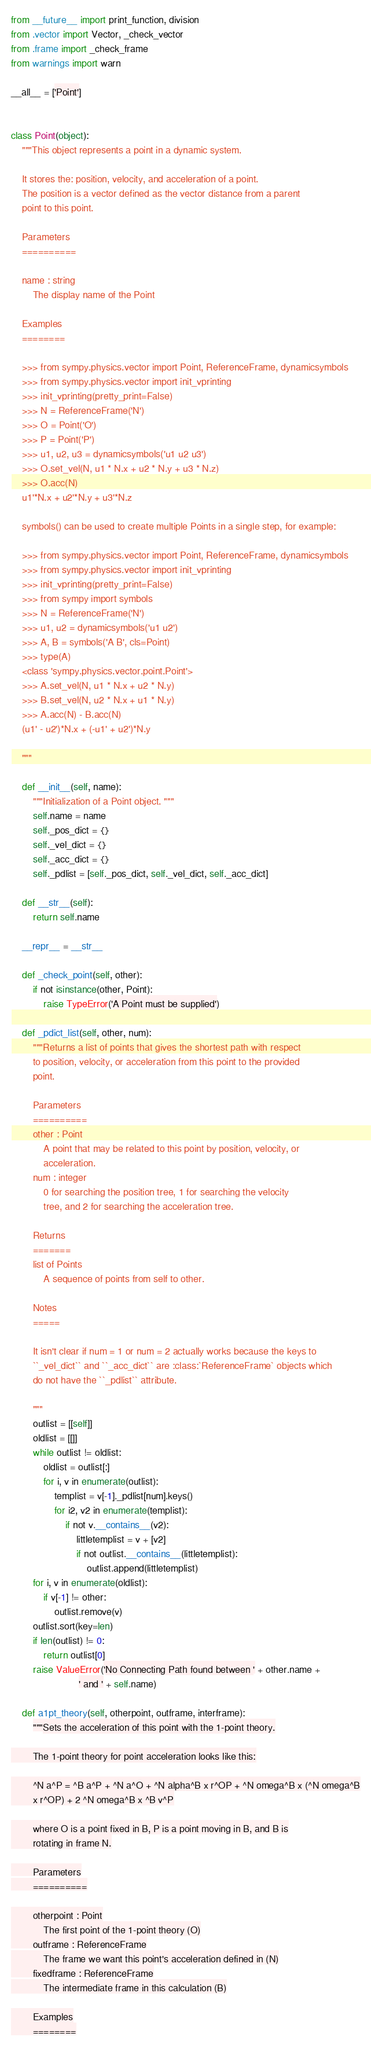Convert code to text. <code><loc_0><loc_0><loc_500><loc_500><_Python_>from __future__ import print_function, division
from .vector import Vector, _check_vector
from .frame import _check_frame
from warnings import warn

__all__ = ['Point']


class Point(object):
    """This object represents a point in a dynamic system.

    It stores the: position, velocity, and acceleration of a point.
    The position is a vector defined as the vector distance from a parent
    point to this point.

    Parameters
    ==========

    name : string
        The display name of the Point

    Examples
    ========

    >>> from sympy.physics.vector import Point, ReferenceFrame, dynamicsymbols
    >>> from sympy.physics.vector import init_vprinting
    >>> init_vprinting(pretty_print=False)
    >>> N = ReferenceFrame('N')
    >>> O = Point('O')
    >>> P = Point('P')
    >>> u1, u2, u3 = dynamicsymbols('u1 u2 u3')
    >>> O.set_vel(N, u1 * N.x + u2 * N.y + u3 * N.z)
    >>> O.acc(N)
    u1'*N.x + u2'*N.y + u3'*N.z

    symbols() can be used to create multiple Points in a single step, for example:

    >>> from sympy.physics.vector import Point, ReferenceFrame, dynamicsymbols
    >>> from sympy.physics.vector import init_vprinting
    >>> init_vprinting(pretty_print=False)
    >>> from sympy import symbols
    >>> N = ReferenceFrame('N')
    >>> u1, u2 = dynamicsymbols('u1 u2')
    >>> A, B = symbols('A B', cls=Point)
    >>> type(A)
    <class 'sympy.physics.vector.point.Point'>
    >>> A.set_vel(N, u1 * N.x + u2 * N.y)
    >>> B.set_vel(N, u2 * N.x + u1 * N.y)
    >>> A.acc(N) - B.acc(N)
    (u1' - u2')*N.x + (-u1' + u2')*N.y

    """

    def __init__(self, name):
        """Initialization of a Point object. """
        self.name = name
        self._pos_dict = {}
        self._vel_dict = {}
        self._acc_dict = {}
        self._pdlist = [self._pos_dict, self._vel_dict, self._acc_dict]

    def __str__(self):
        return self.name

    __repr__ = __str__

    def _check_point(self, other):
        if not isinstance(other, Point):
            raise TypeError('A Point must be supplied')

    def _pdict_list(self, other, num):
        """Returns a list of points that gives the shortest path with respect
        to position, velocity, or acceleration from this point to the provided
        point.

        Parameters
        ==========
        other : Point
            A point that may be related to this point by position, velocity, or
            acceleration.
        num : integer
            0 for searching the position tree, 1 for searching the velocity
            tree, and 2 for searching the acceleration tree.

        Returns
        =======
        list of Points
            A sequence of points from self to other.

        Notes
        =====

        It isn't clear if num = 1 or num = 2 actually works because the keys to
        ``_vel_dict`` and ``_acc_dict`` are :class:`ReferenceFrame` objects which
        do not have the ``_pdlist`` attribute.

        """
        outlist = [[self]]
        oldlist = [[]]
        while outlist != oldlist:
            oldlist = outlist[:]
            for i, v in enumerate(outlist):
                templist = v[-1]._pdlist[num].keys()
                for i2, v2 in enumerate(templist):
                    if not v.__contains__(v2):
                        littletemplist = v + [v2]
                        if not outlist.__contains__(littletemplist):
                            outlist.append(littletemplist)
        for i, v in enumerate(oldlist):
            if v[-1] != other:
                outlist.remove(v)
        outlist.sort(key=len)
        if len(outlist) != 0:
            return outlist[0]
        raise ValueError('No Connecting Path found between ' + other.name +
                         ' and ' + self.name)

    def a1pt_theory(self, otherpoint, outframe, interframe):
        """Sets the acceleration of this point with the 1-point theory.

        The 1-point theory for point acceleration looks like this:

        ^N a^P = ^B a^P + ^N a^O + ^N alpha^B x r^OP + ^N omega^B x (^N omega^B
        x r^OP) + 2 ^N omega^B x ^B v^P

        where O is a point fixed in B, P is a point moving in B, and B is
        rotating in frame N.

        Parameters
        ==========

        otherpoint : Point
            The first point of the 1-point theory (O)
        outframe : ReferenceFrame
            The frame we want this point's acceleration defined in (N)
        fixedframe : ReferenceFrame
            The intermediate frame in this calculation (B)

        Examples
        ========
</code> 